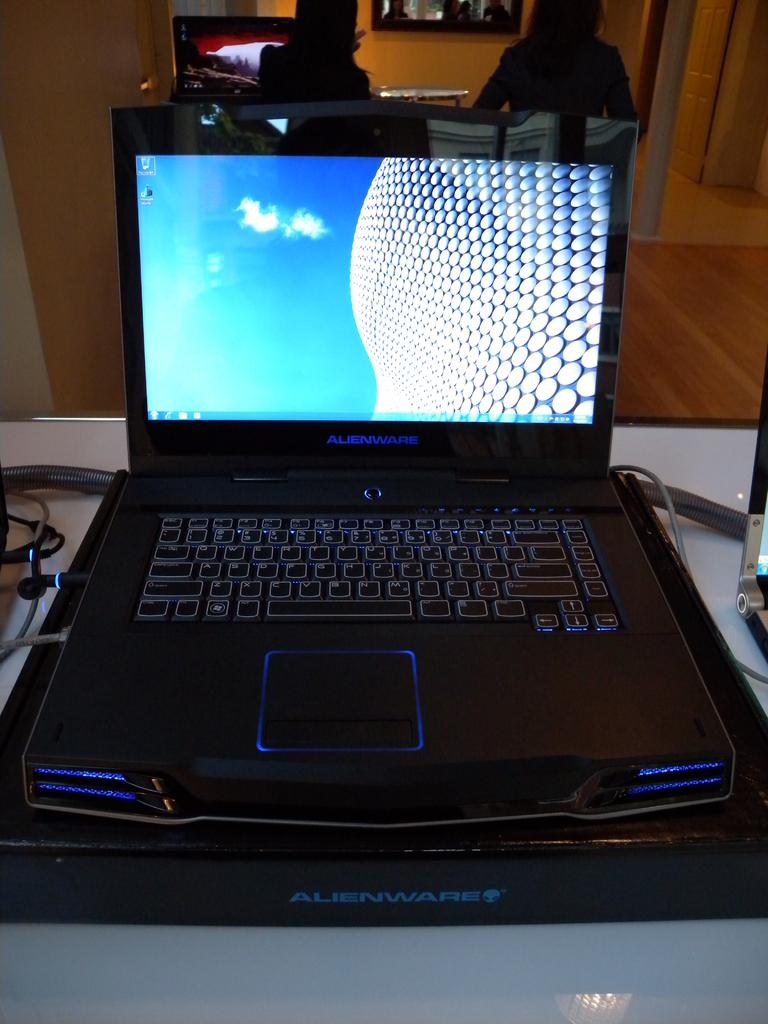Provide a one-sentence caption for the provided image. An Alienware brand computer is opened up to the home screen. 